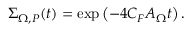Convert formula to latex. <formula><loc_0><loc_0><loc_500><loc_500>\Sigma _ { \Omega , P } ( t ) = \exp \left ( - 4 C _ { F } A _ { \Omega } t \right ) .</formula> 